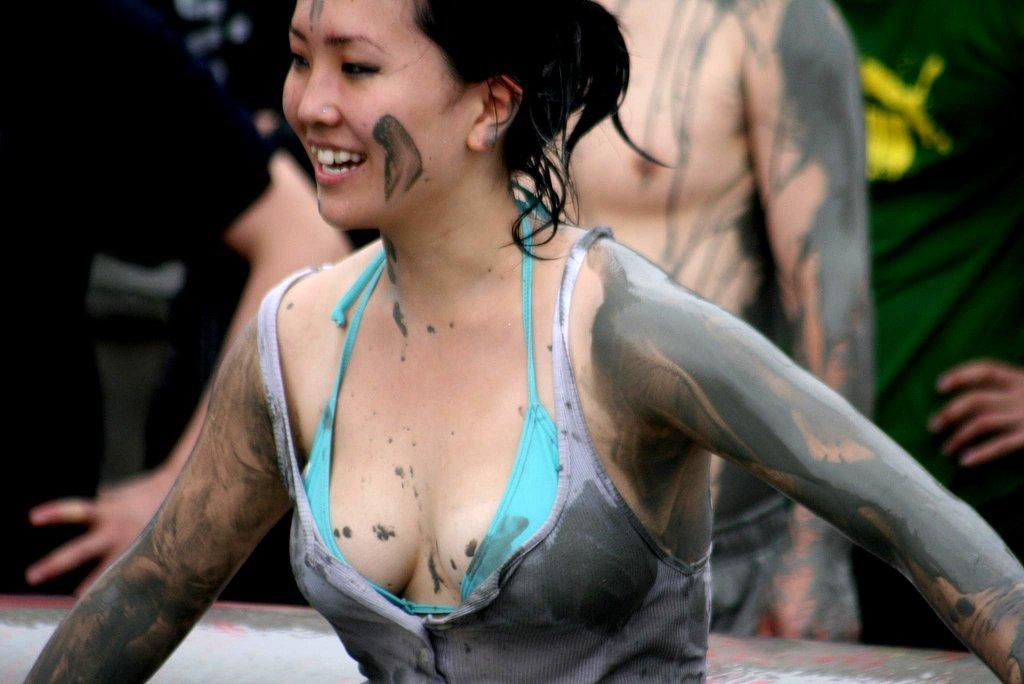Describe this image in one or two sentences. In this image we can see a woman and in the background there are few persons and an object. 